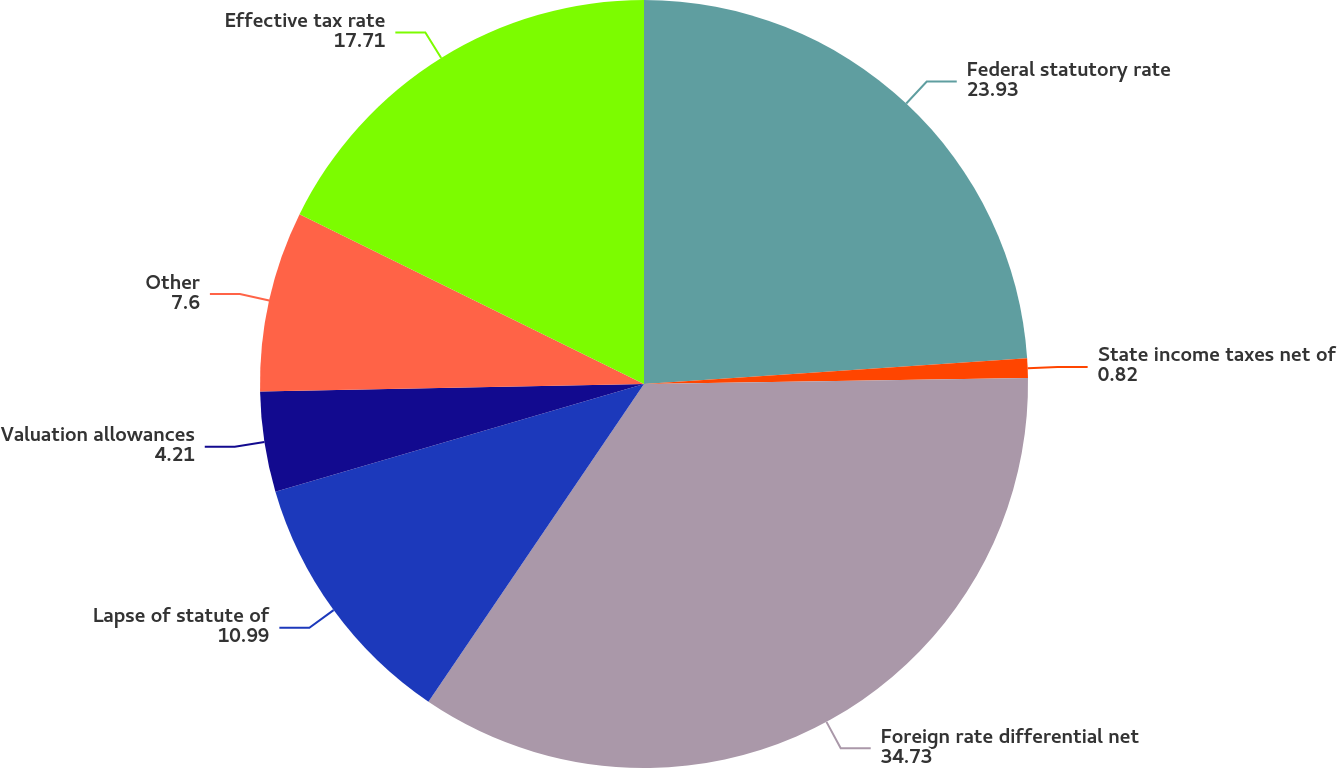<chart> <loc_0><loc_0><loc_500><loc_500><pie_chart><fcel>Federal statutory rate<fcel>State income taxes net of<fcel>Foreign rate differential net<fcel>Lapse of statute of<fcel>Valuation allowances<fcel>Other<fcel>Effective tax rate<nl><fcel>23.93%<fcel>0.82%<fcel>34.73%<fcel>10.99%<fcel>4.21%<fcel>7.6%<fcel>17.71%<nl></chart> 